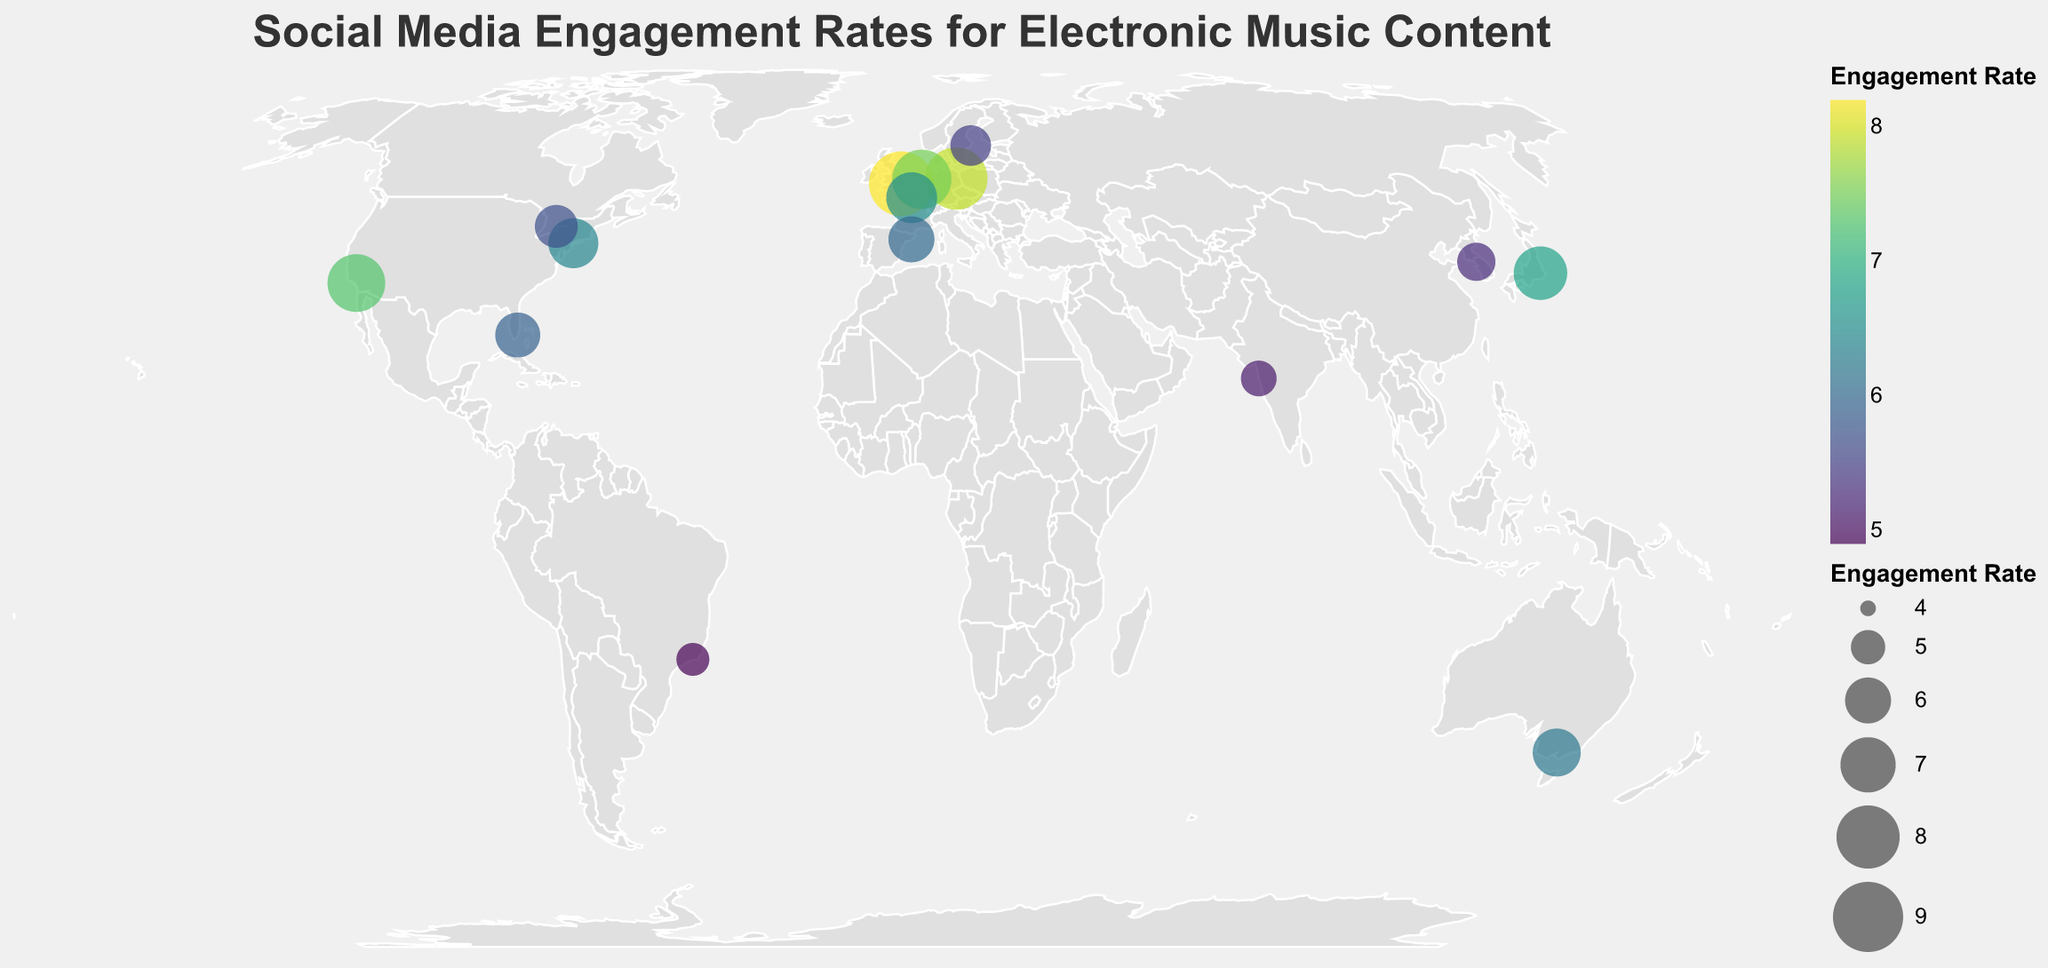What is the title of the figure? The title is displayed in a prominent position at the top of the figure and provides an overview of what the figure depicts.
Answer: Social Media Engagement Rates for Electronic Music Content Which city has the highest engagement rate for electronic music content? By examining the size and color of the circles on the map, we can identify the largest and most vibrant circle. The tooltip data confirms this identification.
Answer: London Which city has the lowest engagement rate for electronic music content? The smallest and least vibrant circle on the map indicates the city with the lowest engagement rate. The tooltip data confirms this identification.
Answer: Rio de Janeiro What is the difference in engagement rates between the cities with the highest and lowest rates? Using the engagement rates from the previous answers, we subtract the lowest rate from the highest rate: 8.2 (London) - 4.9 (Rio de Janeiro).
Answer: 3.3 How many cities in the United States are included in the figure? Counting the number of data points located in the United States as labeled in the tooltip data reveals the number of relevant cities.
Answer: 3 Which city in Canada has an engagement rate, and what is its value? By examining the tooltip data for the city located in Canada, we can point out its name and corresponding engagement rate.
Answer: Toronto, 5.7 Compare the engagement rates of the two highest ranked cities. What is the difference between them? The two highest engagement rates belong to London (8.2) and Berlin (7.9). Subtracting the engagement rate of Berlin from that of London gives us the difference.
Answer: 0.3 Which continents are represented by the cities in the figure? By examining the geographic locations of the cities and identifying which continents they are situated on, we compile the list of represented continents.
Answer: Europe, North America, Asia, Australia, South America Between Paris and Melbourne, which city has a higher engagement rate and by how much? By comparing the engagement rates of Paris (6.5) and Melbourne (6.2) and subtracting the lower rate from the higher one, we find the difference.
Answer: Paris, 0.3 What is the average engagement rate of the cities in Europe? First, identify the cities in Europe: London, Berlin, Amsterdam, Paris, Barcelona, and Stockholm. Calculate the average by summing their engagement rates and dividing by the number of cities: (8.2 + 7.9 + 7.5 + 6.5 + 6.0 + 5.5) / 6.
Answer: 6.93 